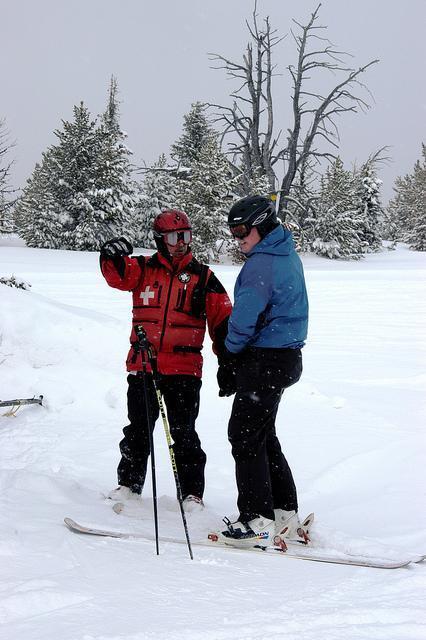How many poles are there?
Give a very brief answer. 2. How many people are there?
Give a very brief answer. 2. 